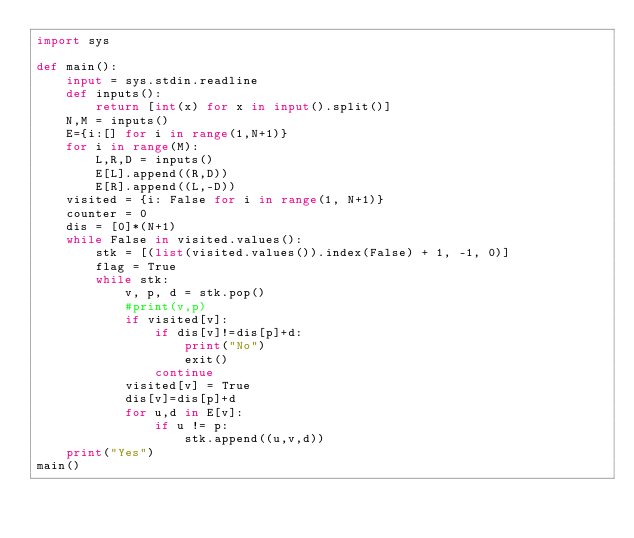<code> <loc_0><loc_0><loc_500><loc_500><_Python_>import sys

def main():    
    input = sys.stdin.readline
    def inputs():
        return [int(x) for x in input().split()]
    N,M = inputs()
    E={i:[] for i in range(1,N+1)}
    for i in range(M):
        L,R,D = inputs()
        E[L].append((R,D))
        E[R].append((L,-D))
    visited = {i: False for i in range(1, N+1)}
    counter = 0
    dis = [0]*(N+1)
    while False in visited.values():
        stk = [(list(visited.values()).index(False) + 1, -1, 0)]
        flag = True
        while stk:
            v, p, d = stk.pop()
            #print(v,p)
            if visited[v]:
                if dis[v]!=dis[p]+d:
                    print("No")
                    exit()
                continue
            visited[v] = True
            dis[v]=dis[p]+d
            for u,d in E[v]:
                if u != p:
                    stk.append((u,v,d))
    print("Yes")
main()</code> 